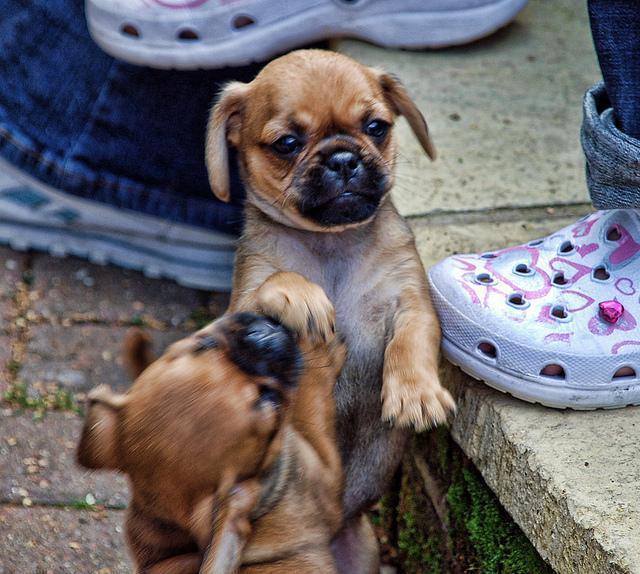How many dogs are in the photo?
Give a very brief answer. 2. How many people can be seen?
Give a very brief answer. 2. 